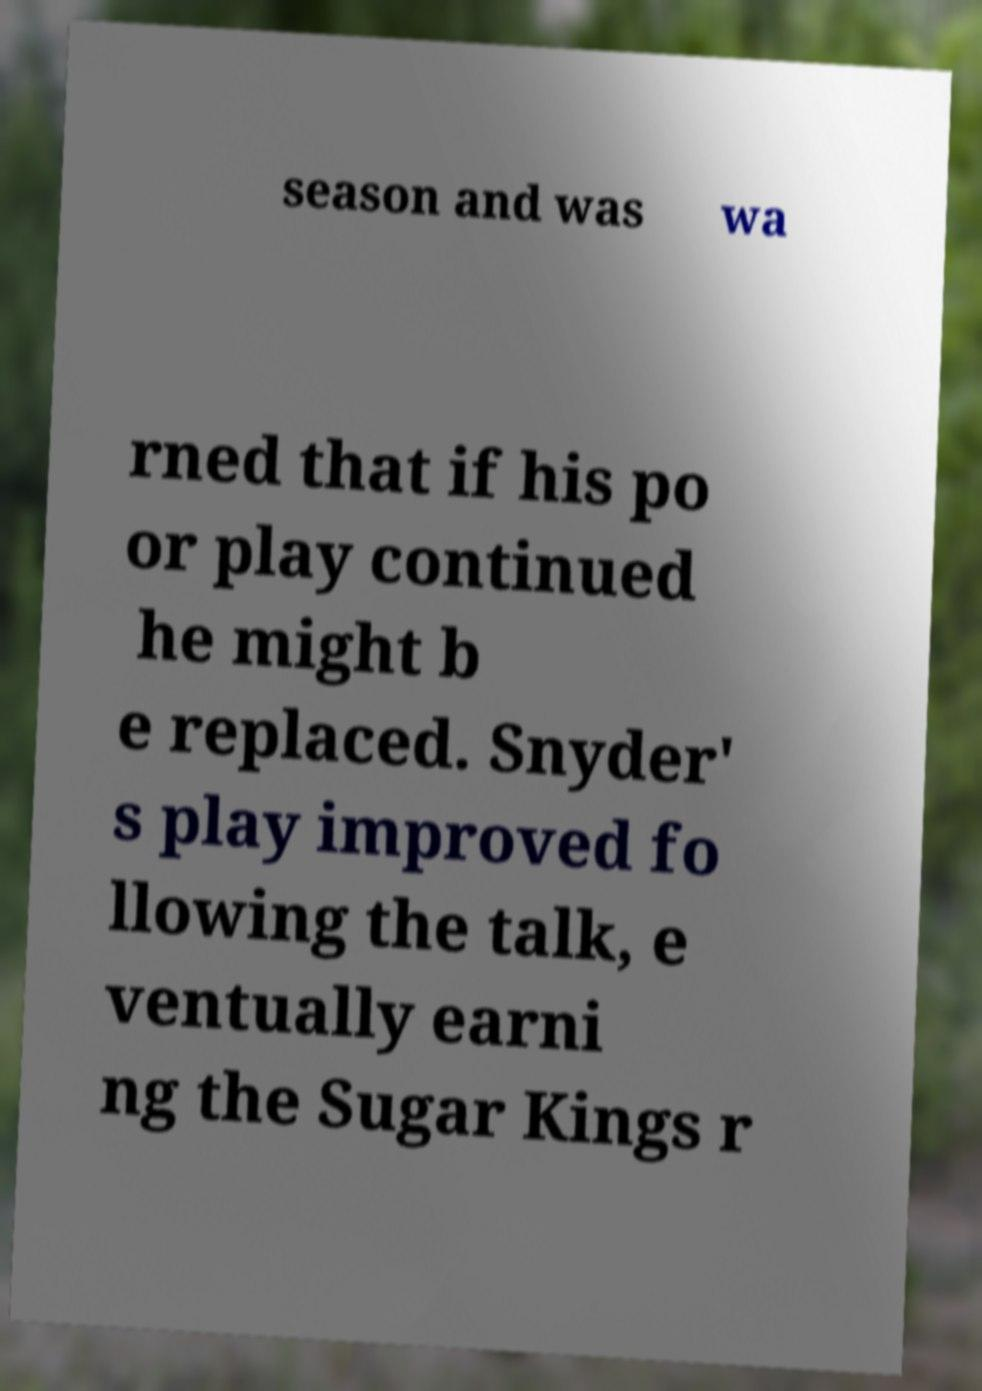Please identify and transcribe the text found in this image. season and was wa rned that if his po or play continued he might b e replaced. Snyder' s play improved fo llowing the talk, e ventually earni ng the Sugar Kings r 